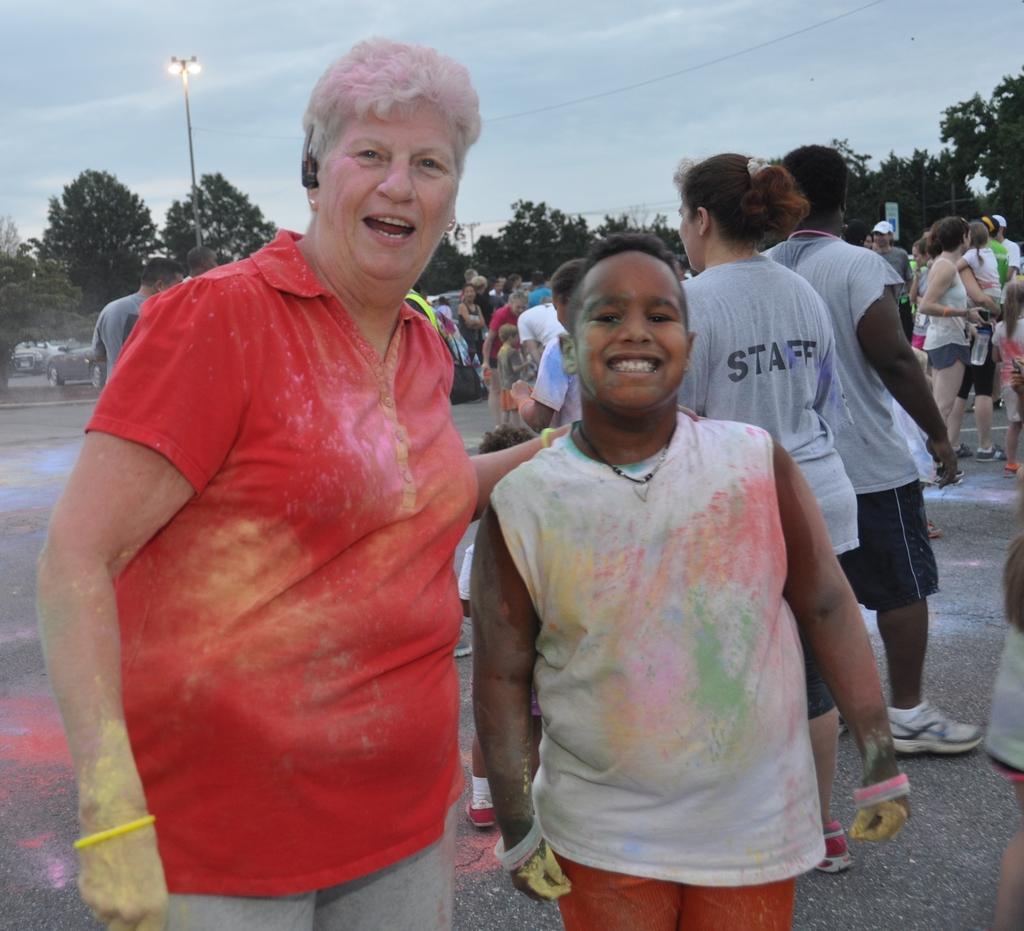Could you give a brief overview of what you see in this image? In the middle of the image two persons are standing and smiling. Behind them few people are standing and holding some bottles. Behind them there are some trees and poles and vehicles. At the top of the image there are some clouds in the sky. 